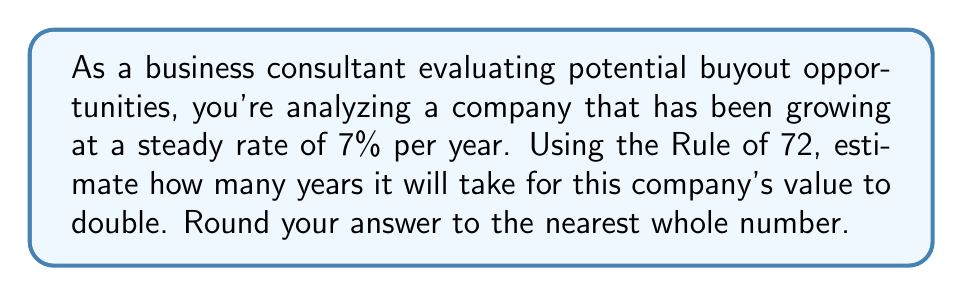Could you help me with this problem? The Rule of 72 is a quick estimation method used in finance to determine how long it will take for an investment to double, given a fixed annual rate of return. It's particularly useful for business consultants who need to make rapid assessments of growth potential.

The formula for the Rule of 72 is:

$$ T \approx \frac{72}{r} $$

Where:
$T$ = Time to double (in years)
$r$ = Annual growth rate (as a percentage)

In this case, we're given:
$r = 7\%$ (annual growth rate)

Let's plug this into our formula:

$$ T \approx \frac{72}{7} $$

$$ T \approx 10.29 \text{ years} $$

Rounding to the nearest whole number:

$$ T \approx 10 \text{ years} $$

It's important to note that the Rule of 72 is an approximation. For more precise calculations, especially for higher growth rates, we would use the exact formula involving logarithms:

$$ T = \frac{\ln(2)}{\ln(1 + r)} $$

Where $\ln$ is the natural logarithm. However, for quick estimations in business scenarios, the Rule of 72 provides a sufficiently accurate approximation.
Answer: 10 years 